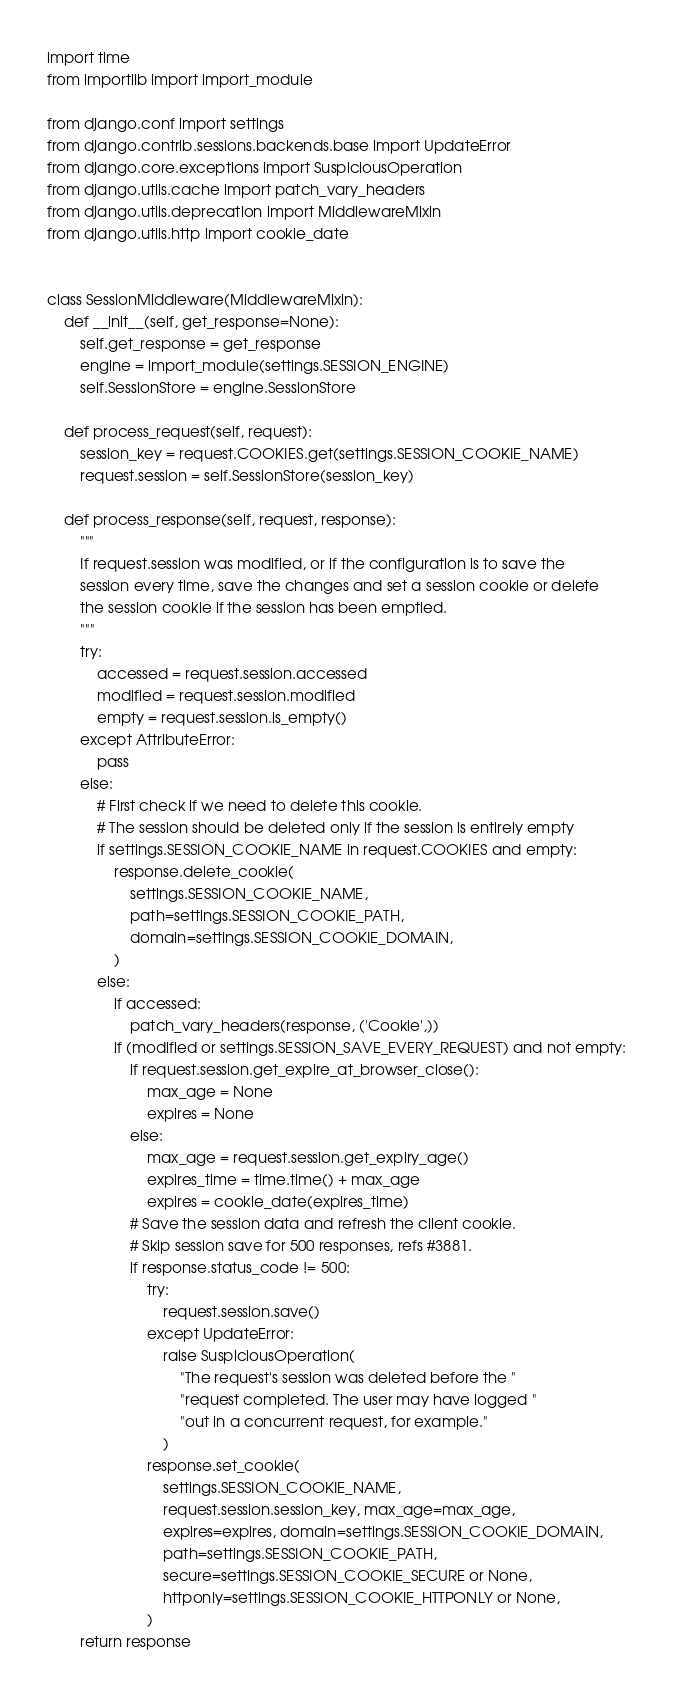Convert code to text. <code><loc_0><loc_0><loc_500><loc_500><_Python_>import time
from importlib import import_module

from django.conf import settings
from django.contrib.sessions.backends.base import UpdateError
from django.core.exceptions import SuspiciousOperation
from django.utils.cache import patch_vary_headers
from django.utils.deprecation import MiddlewareMixin
from django.utils.http import cookie_date


class SessionMiddleware(MiddlewareMixin):
    def __init__(self, get_response=None):
        self.get_response = get_response
        engine = import_module(settings.SESSION_ENGINE)
        self.SessionStore = engine.SessionStore

    def process_request(self, request):
        session_key = request.COOKIES.get(settings.SESSION_COOKIE_NAME)
        request.session = self.SessionStore(session_key)

    def process_response(self, request, response):
        """
        If request.session was modified, or if the configuration is to save the
        session every time, save the changes and set a session cookie or delete
        the session cookie if the session has been emptied.
        """
        try:
            accessed = request.session.accessed
            modified = request.session.modified
            empty = request.session.is_empty()
        except AttributeError:
            pass
        else:
            # First check if we need to delete this cookie.
            # The session should be deleted only if the session is entirely empty
            if settings.SESSION_COOKIE_NAME in request.COOKIES and empty:
                response.delete_cookie(
                    settings.SESSION_COOKIE_NAME,
                    path=settings.SESSION_COOKIE_PATH,
                    domain=settings.SESSION_COOKIE_DOMAIN,
                )
            else:
                if accessed:
                    patch_vary_headers(response, ('Cookie',))
                if (modified or settings.SESSION_SAVE_EVERY_REQUEST) and not empty:
                    if request.session.get_expire_at_browser_close():
                        max_age = None
                        expires = None
                    else:
                        max_age = request.session.get_expiry_age()
                        expires_time = time.time() + max_age
                        expires = cookie_date(expires_time)
                    # Save the session data and refresh the client cookie.
                    # Skip session save for 500 responses, refs #3881.
                    if response.status_code != 500:
                        try:
                            request.session.save()
                        except UpdateError:
                            raise SuspiciousOperation(
                                "The request's session was deleted before the "
                                "request completed. The user may have logged "
                                "out in a concurrent request, for example."
                            )
                        response.set_cookie(
                            settings.SESSION_COOKIE_NAME,
                            request.session.session_key, max_age=max_age,
                            expires=expires, domain=settings.SESSION_COOKIE_DOMAIN,
                            path=settings.SESSION_COOKIE_PATH,
                            secure=settings.SESSION_COOKIE_SECURE or None,
                            httponly=settings.SESSION_COOKIE_HTTPONLY or None,
                        )
        return response
</code> 